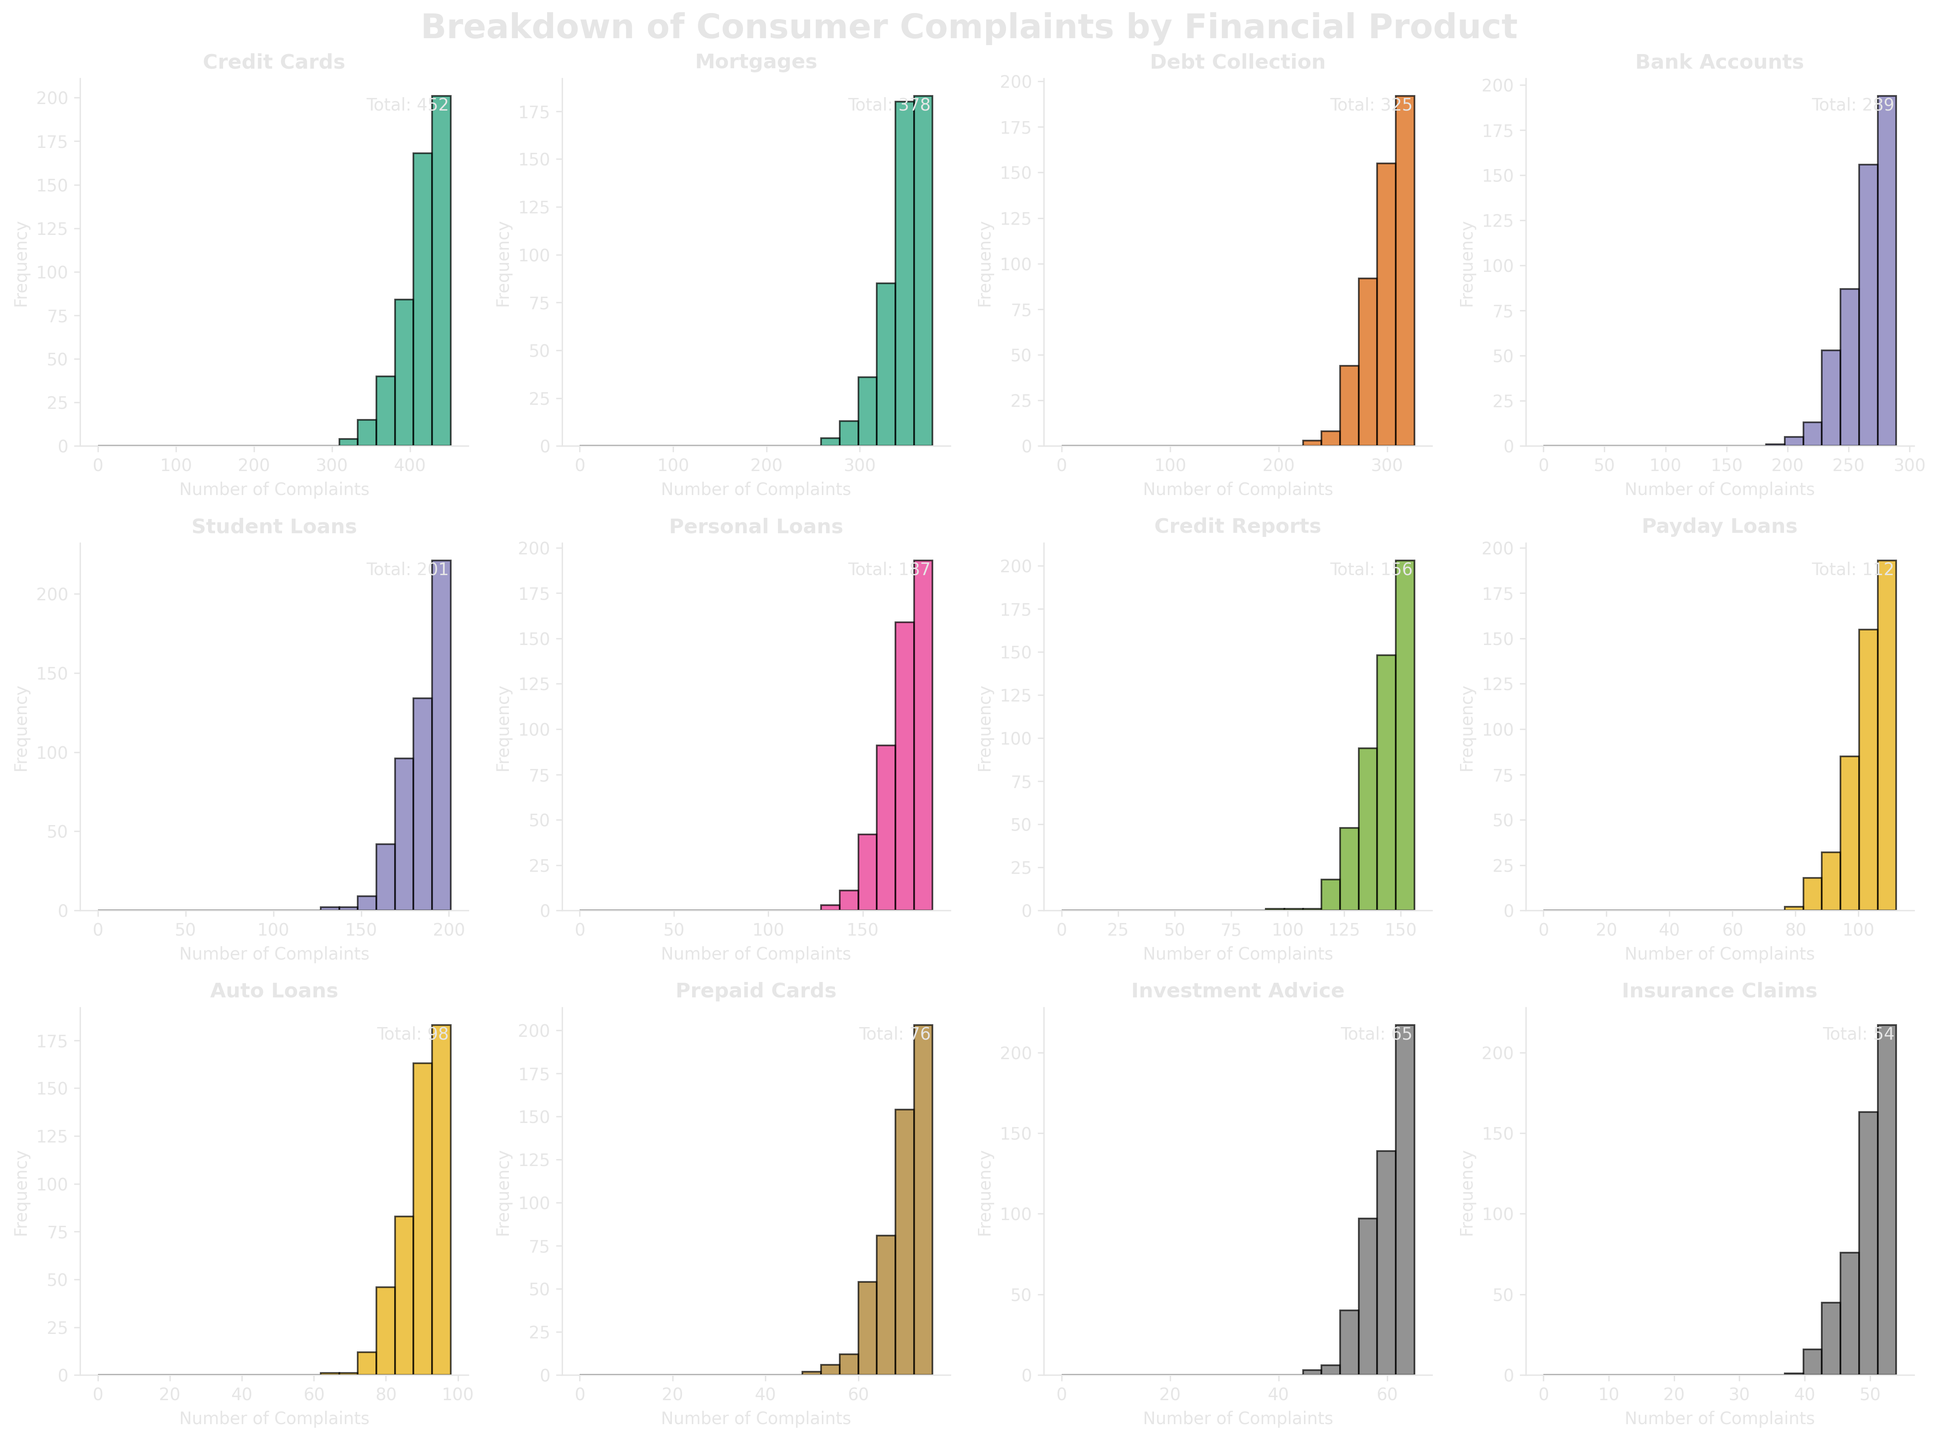What is the title of the figure? The title of the figure is displayed at the top of the plot and describes the main subject. Here, it's "Breakdown of Consumer Complaints by Financial Product".
Answer: Breakdown of Consumer Complaints by Financial Product How many financial product types are shown? The figure consists of several subplots, each titled with a different financial product. Count the number of unique titles. Here, there are 12 financial products.
Answer: 12 Which financial product has the highest number of complaints? The histogram titled "Credit Cards" has the largest number noted at the top right corner, which is the highest number of complaints.
Answer: Credit Cards Compare the total number of complaints about "Credit Reports" and "Investment Advice". Which one has more complaints? From the figure, "Credit Reports" shows a total of 156 complaints, while "Investment Advice" shows 65 complaints. 156 is greater than 65.
Answer: Credit Reports What is the sum of complaints for "Mortgages" and "Auto Loans"? Find the total number of complaints listed in the top right of the "Mortgages" subplot (378) and the "Auto Loans" subplot (98). Add these two numbers: 378 + 98 = 476.
Answer: 476 Which financial product has the least number of complaints? The histogram with the lowest number displayed in the top right corner is "Insurance Claims", which shows 54 complaints.
Answer: Insurance Claims What is the average number of complaints for "Credit Cards", "Mortgages", and "Debt Collection"? Sum the total complaints for these three products: 452 (Credit Cards) + 378 (Mortgages) + 325 (Debt Collection) = 1155. Divide the sum by 3: 1155 / 3 = 385.
Answer: 385 Is the number of complaints about "Student Loans" greater than that about "Bank Accounts"? The subplot for "Student Loans" shows 201 complaints, and "Bank Accounts" shows 289 complaints. 201 is not greater than 289.
Answer: No How does the frequency distribution of complaints differ between "Payday Loans" and "Prepaid Cards"? Compare the shape and spread of the histograms. The "Payday Loans" histogram may show a different spread and height of bars compared to "Prepaid Cards", indicating differences in the variability and frequency of complaints within the bin ranges.
Answer: Varies What patterns are observable in the complaints data across different financial products? Analyzing the histograms collectively, one can observe that each product has varying distributions, counts, and spreads. Products like "Credit Cards" and "Mortgages" have higher complaints, whereas products like "Insurance Claims" have notably fewer complaints. Additionally, the spread of the histograms may suggest different variability in complaint numbers.
Answer: Varies 